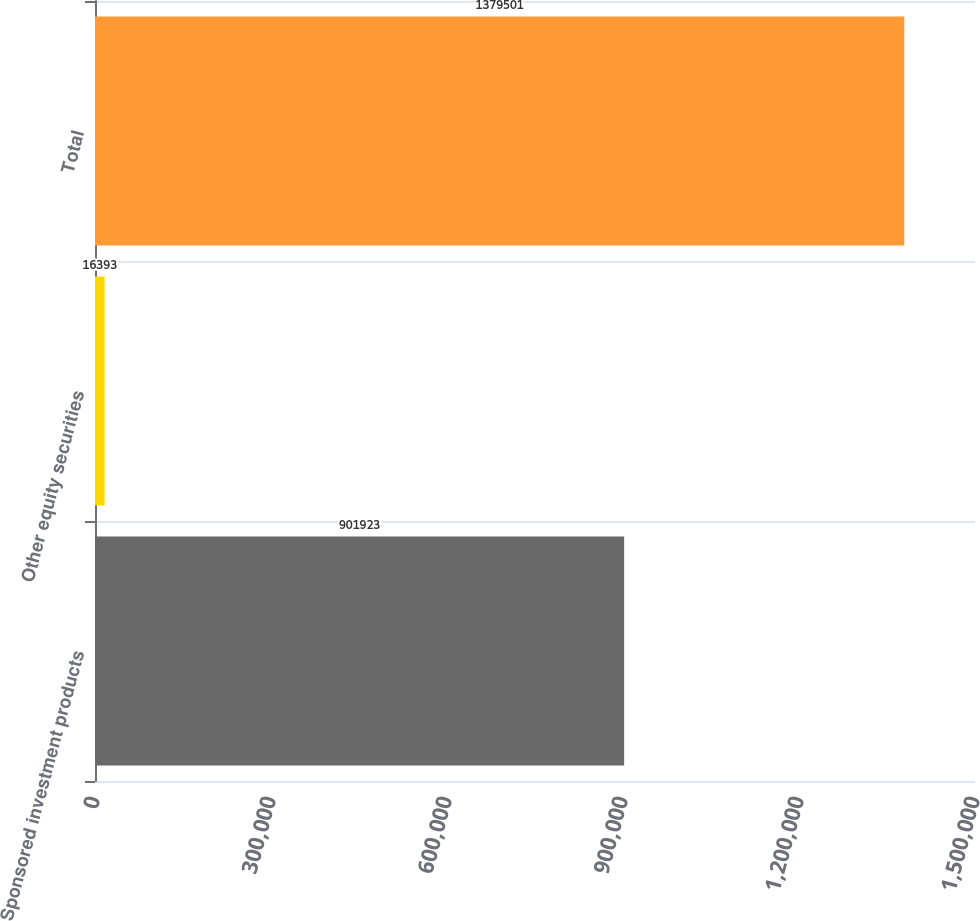Convert chart. <chart><loc_0><loc_0><loc_500><loc_500><bar_chart><fcel>Sponsored investment products<fcel>Other equity securities<fcel>Total<nl><fcel>901923<fcel>16393<fcel>1.3795e+06<nl></chart> 